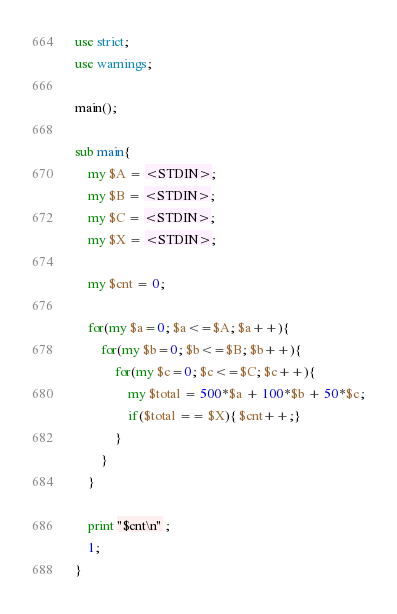Convert code to text. <code><loc_0><loc_0><loc_500><loc_500><_Perl_>use strict;
use warnings;

main();

sub main{
	my $A = <STDIN>;
	my $B = <STDIN>;
	my $C = <STDIN>;
	my $X = <STDIN>;

	my $cnt = 0;

	for(my $a=0; $a<=$A; $a++){
		for(my $b=0; $b<=$B; $b++){
			for(my $c=0; $c<=$C; $c++){
				my $total = 500*$a + 100*$b + 50*$c;
				if($total == $X){ $cnt++;}
			}
		}
	}
	
	print "$cnt\n" ;
	1;
}</code> 